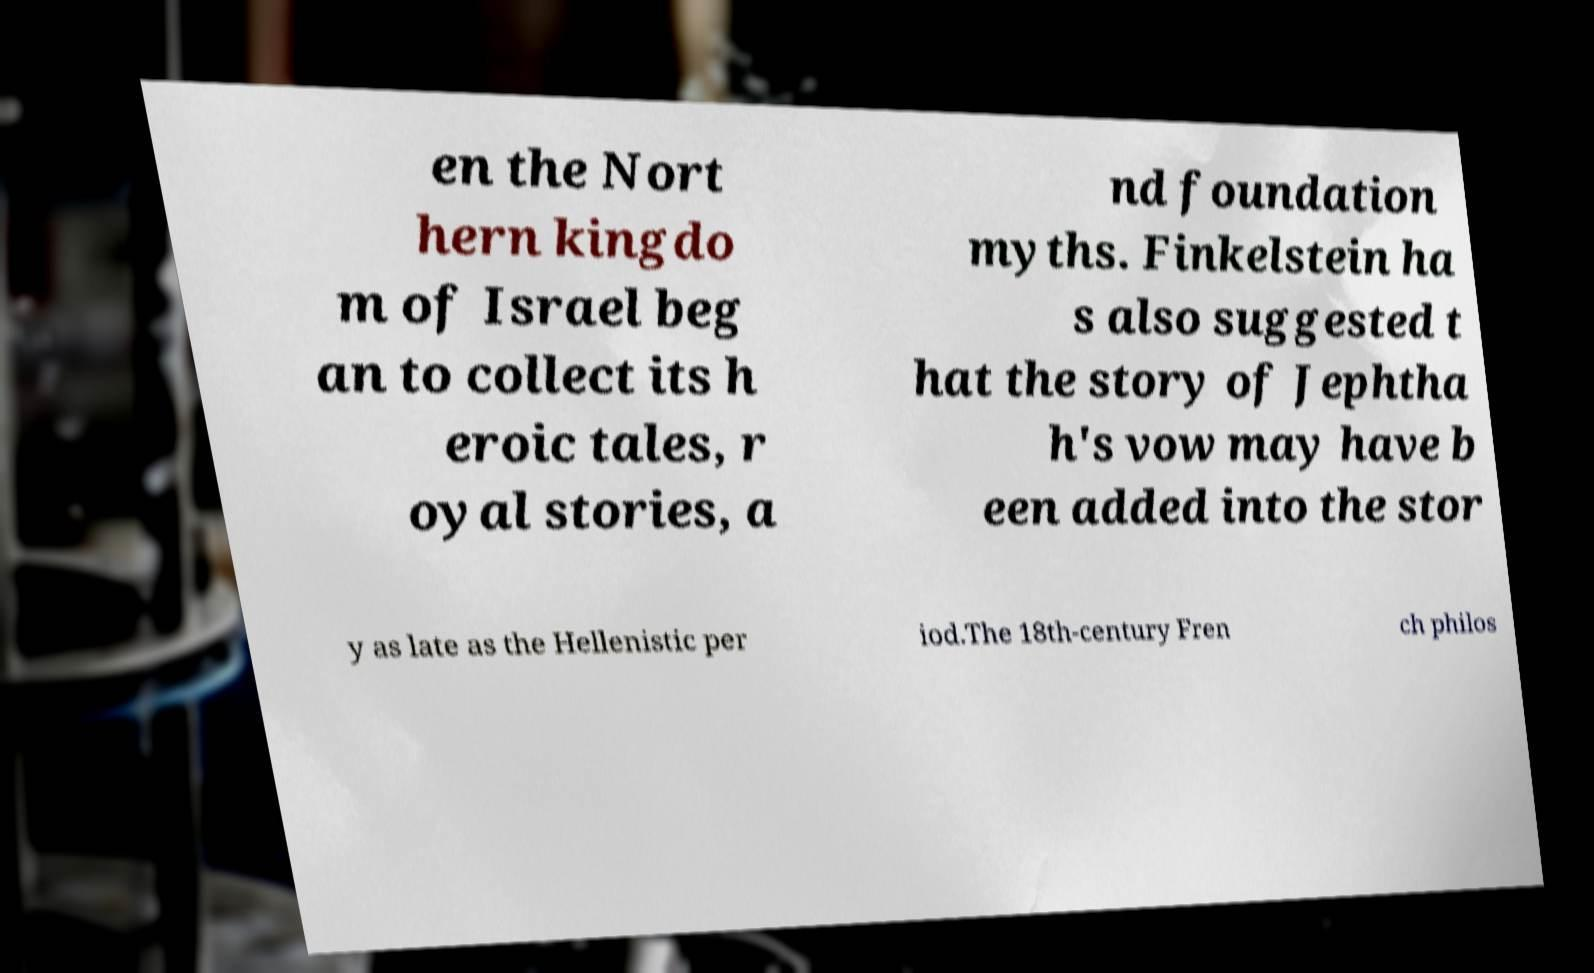Could you assist in decoding the text presented in this image and type it out clearly? en the Nort hern kingdo m of Israel beg an to collect its h eroic tales, r oyal stories, a nd foundation myths. Finkelstein ha s also suggested t hat the story of Jephtha h's vow may have b een added into the stor y as late as the Hellenistic per iod.The 18th-century Fren ch philos 